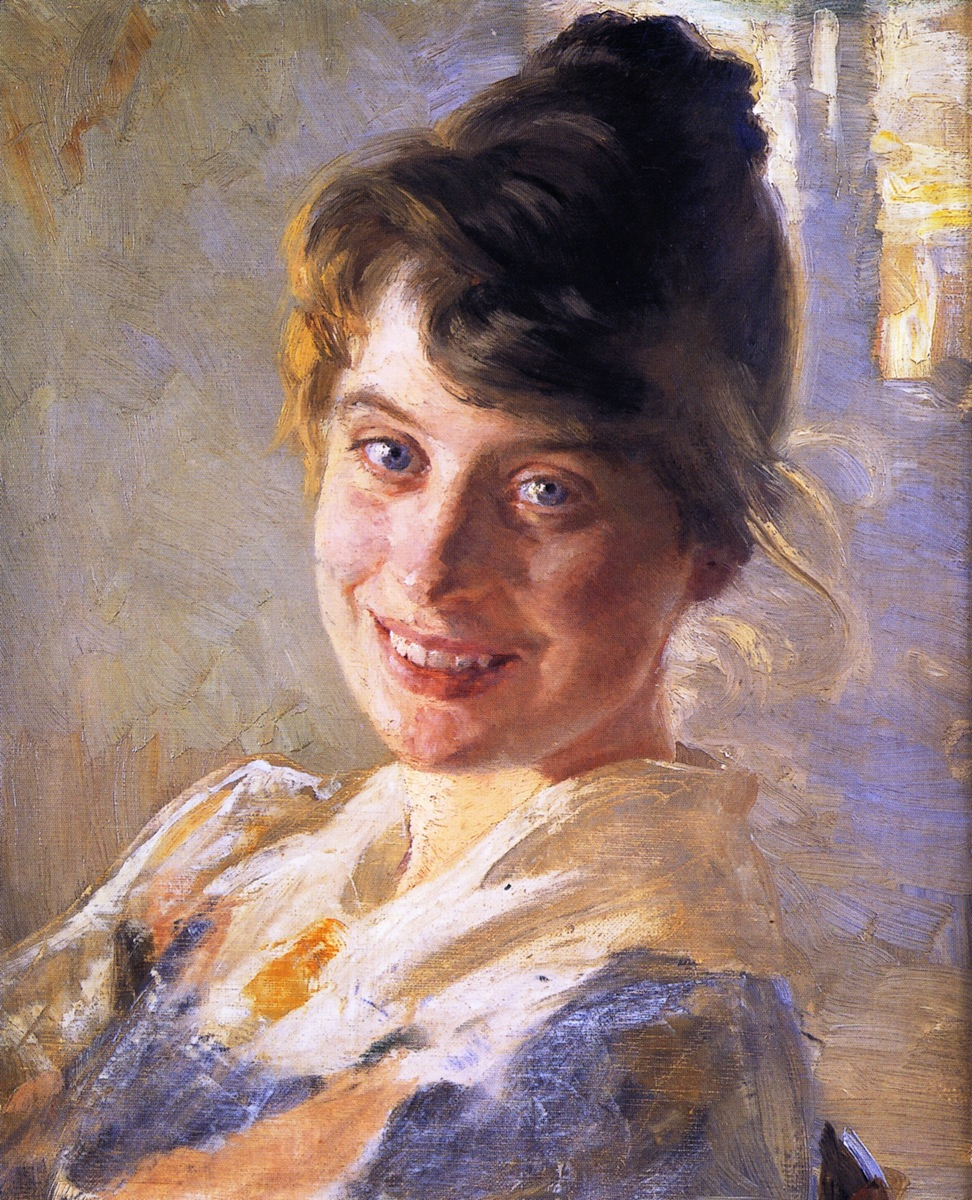Write a detailed description of the given image. The image depicts a portrait of a young woman painted in an impressionist style. She has a warm and genuine smile which brings a cheerful and light-hearted mood to the artwork. The woman is dressed in a white blouse with blue stripes, and her hair is elegantly styled in a loose bun. The background is a beautiful blend of light blues and yellows, contributing to the soft and airy atmosphere of the painting. The artist used loose brushstrokes and a bright color palette, which are characteristic of the impressionist style. This technique, combined with the use of color, creates a sense of warmth and joy that emanates from the artwork. 